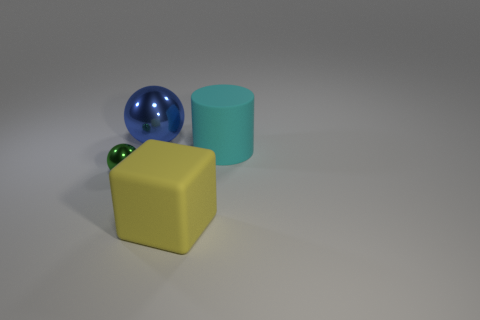How many large objects are rubber objects or green objects? 2 